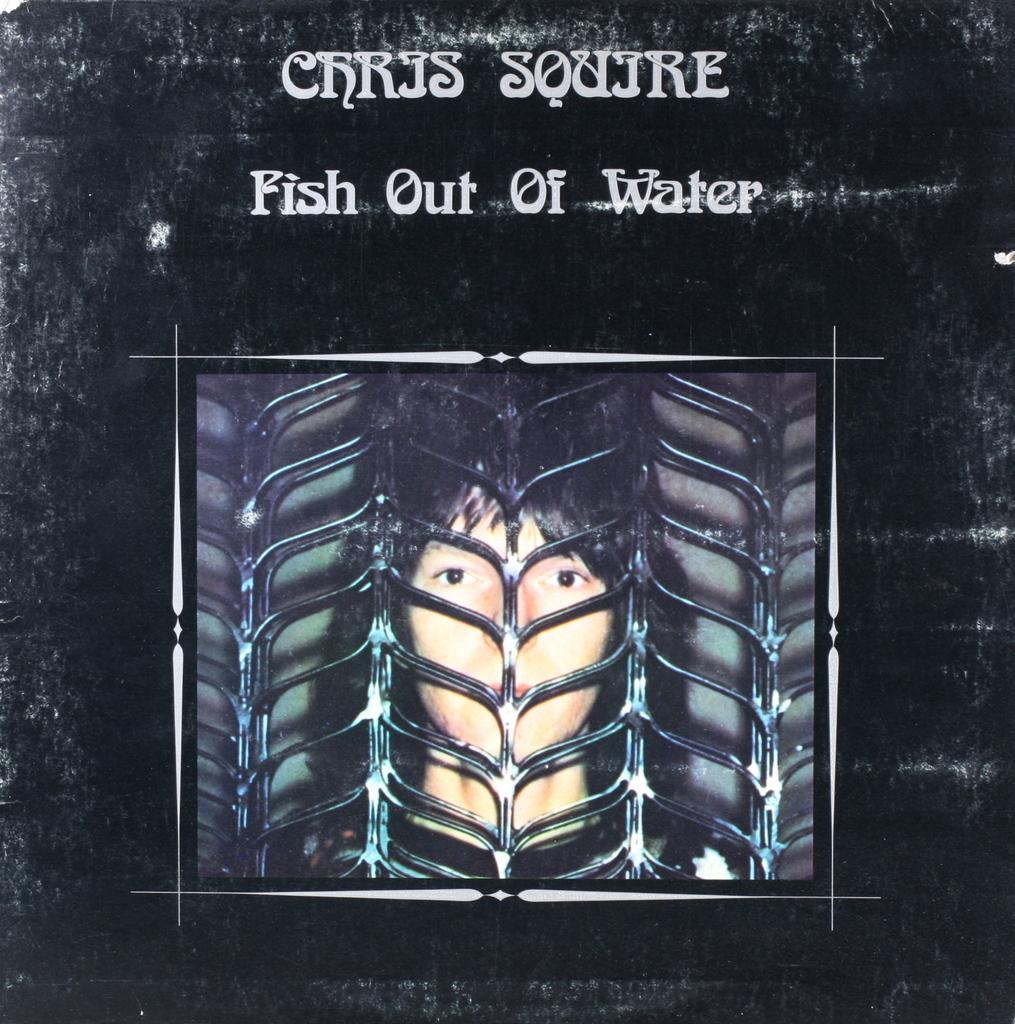What is featured on the poster in the image? There is a poster with text in the image. Can you describe the image behind the grille in the image? There is an image of a person behind a grille in the image. How many clovers are visible in the image? There are no clovers present in the image. What type of vessel is being used by the person behind the grille? There is no vessel visible in the image, as it only features an image of a person behind a grille. 